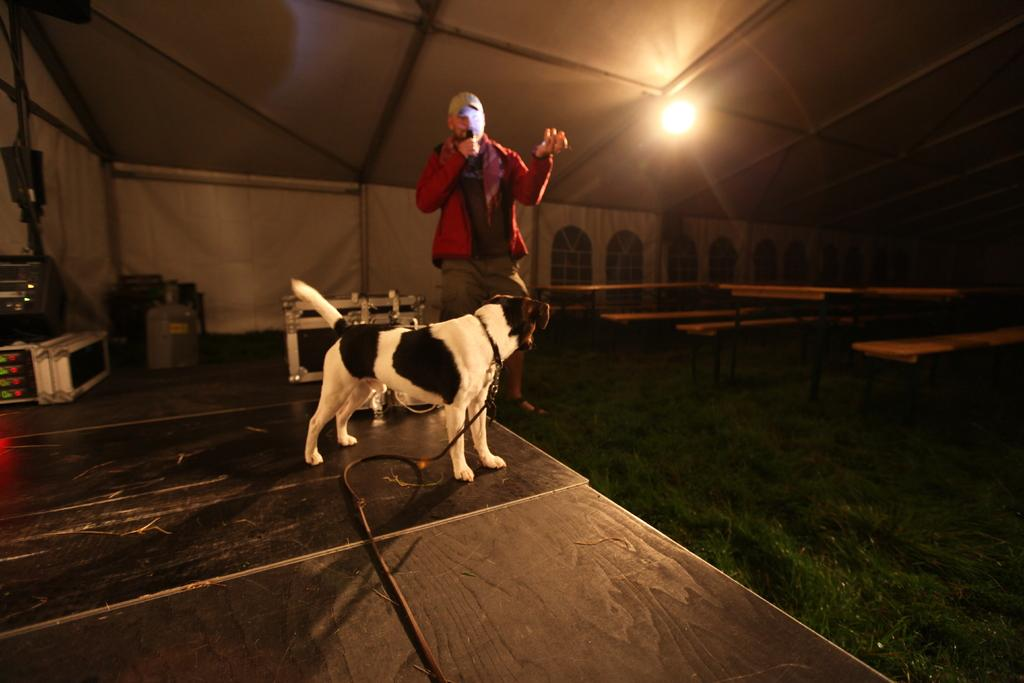What type of structure can be seen in the image? There is a wall in the image. Are there any openings in the wall? Yes, there are windows in the image. What can be seen on the wall? There is a light in the image. What type of animal is present in the image? There is a dog in the image. What is the person in the image wearing? The person is wearing a red color shirt and a cap. What is the person holding in the image? The person is holding a mic. Can you tell me how many needles are visible in the image? There are no needles present in the image. What type of door can be seen in the image? There is no door present in the image. 